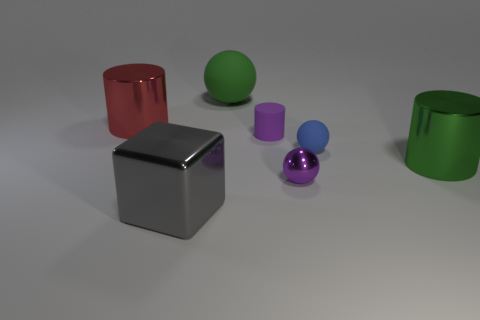Subtract all cylinders. How many objects are left? 4 Add 3 tiny matte things. How many objects exist? 10 Add 4 tiny shiny objects. How many tiny shiny objects exist? 5 Subtract 0 yellow blocks. How many objects are left? 7 Subtract all tiny gray metallic objects. Subtract all small purple shiny spheres. How many objects are left? 6 Add 6 green matte things. How many green matte things are left? 7 